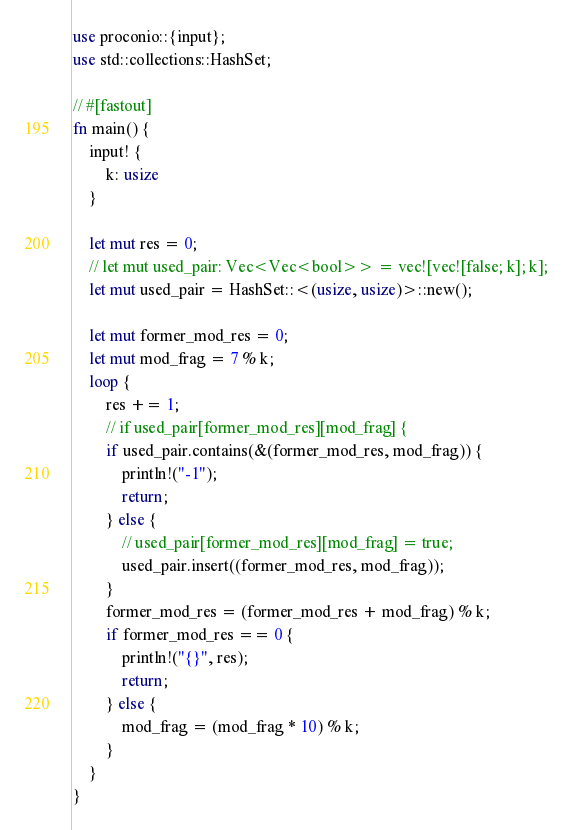<code> <loc_0><loc_0><loc_500><loc_500><_Rust_>use proconio::{input};
use std::collections::HashSet;

// #[fastout]
fn main() {
    input! {
        k: usize
    }

    let mut res = 0;
    // let mut used_pair: Vec<Vec<bool>> = vec![vec![false; k]; k];
    let mut used_pair = HashSet::<(usize, usize)>::new();

    let mut former_mod_res = 0;
    let mut mod_frag = 7 % k;
    loop {
        res += 1;
        // if used_pair[former_mod_res][mod_frag] {
        if used_pair.contains(&(former_mod_res, mod_frag)) {
            println!("-1");
            return;
        } else {
            // used_pair[former_mod_res][mod_frag] = true;
            used_pair.insert((former_mod_res, mod_frag));
        }
        former_mod_res = (former_mod_res + mod_frag) % k;
        if former_mod_res == 0 {
            println!("{}", res);
            return;
        } else {
            mod_frag = (mod_frag * 10) % k;
        }
    }
}
</code> 